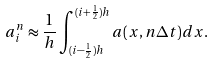Convert formula to latex. <formula><loc_0><loc_0><loc_500><loc_500>a ^ { n } _ { i } \approx \frac { 1 } { h } \int ^ { ( i + \frac { 1 } { 2 } ) h } _ { ( i - \frac { 1 } { 2 } ) h } a ( x , n \Delta t ) d x .</formula> 